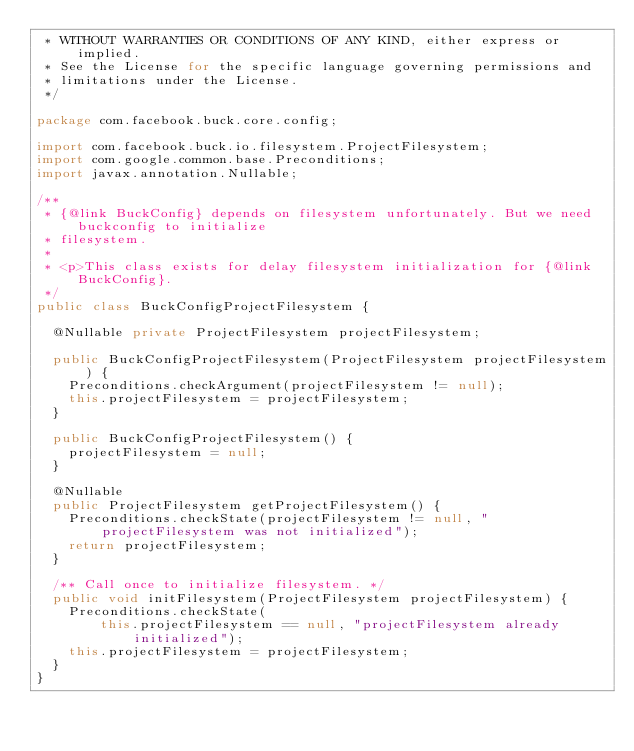<code> <loc_0><loc_0><loc_500><loc_500><_Java_> * WITHOUT WARRANTIES OR CONDITIONS OF ANY KIND, either express or implied.
 * See the License for the specific language governing permissions and
 * limitations under the License.
 */

package com.facebook.buck.core.config;

import com.facebook.buck.io.filesystem.ProjectFilesystem;
import com.google.common.base.Preconditions;
import javax.annotation.Nullable;

/**
 * {@link BuckConfig} depends on filesystem unfortunately. But we need buckconfig to initialize
 * filesystem.
 *
 * <p>This class exists for delay filesystem initialization for {@link BuckConfig}.
 */
public class BuckConfigProjectFilesystem {

  @Nullable private ProjectFilesystem projectFilesystem;

  public BuckConfigProjectFilesystem(ProjectFilesystem projectFilesystem) {
    Preconditions.checkArgument(projectFilesystem != null);
    this.projectFilesystem = projectFilesystem;
  }

  public BuckConfigProjectFilesystem() {
    projectFilesystem = null;
  }

  @Nullable
  public ProjectFilesystem getProjectFilesystem() {
    Preconditions.checkState(projectFilesystem != null, "projectFilesystem was not initialized");
    return projectFilesystem;
  }

  /** Call once to initialize filesystem. */
  public void initFilesystem(ProjectFilesystem projectFilesystem) {
    Preconditions.checkState(
        this.projectFilesystem == null, "projectFilesystem already initialized");
    this.projectFilesystem = projectFilesystem;
  }
}
</code> 